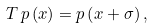Convert formula to latex. <formula><loc_0><loc_0><loc_500><loc_500>T \, p \left ( x \right ) = p \left ( x + \sigma \right ) ,</formula> 